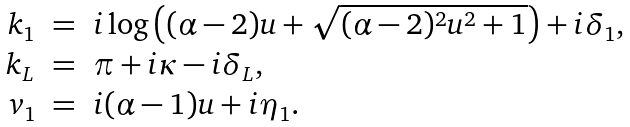<formula> <loc_0><loc_0><loc_500><loc_500>\begin{array} { r c l } k _ { 1 } & = & i \log \left ( ( \alpha - 2 ) u + \sqrt { ( \alpha - 2 ) ^ { 2 } u ^ { 2 } + 1 } \right ) + i \delta _ { 1 } , \\ k _ { L } & = & \pi + i \kappa - i \delta _ { L } , \\ v _ { 1 } & = & i ( \alpha - 1 ) u + i \eta _ { 1 } . \end{array}</formula> 